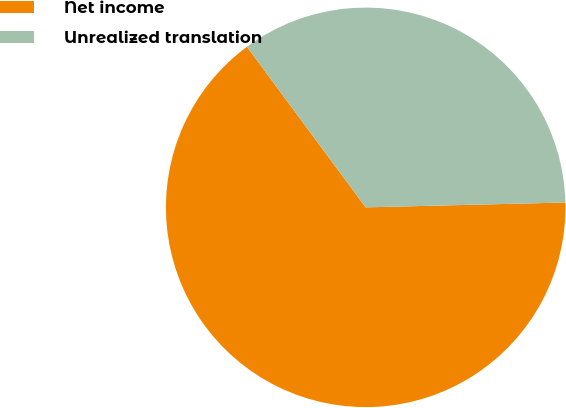Convert chart to OTSL. <chart><loc_0><loc_0><loc_500><loc_500><pie_chart><fcel>Net income<fcel>Unrealized translation<nl><fcel>65.25%<fcel>34.75%<nl></chart> 